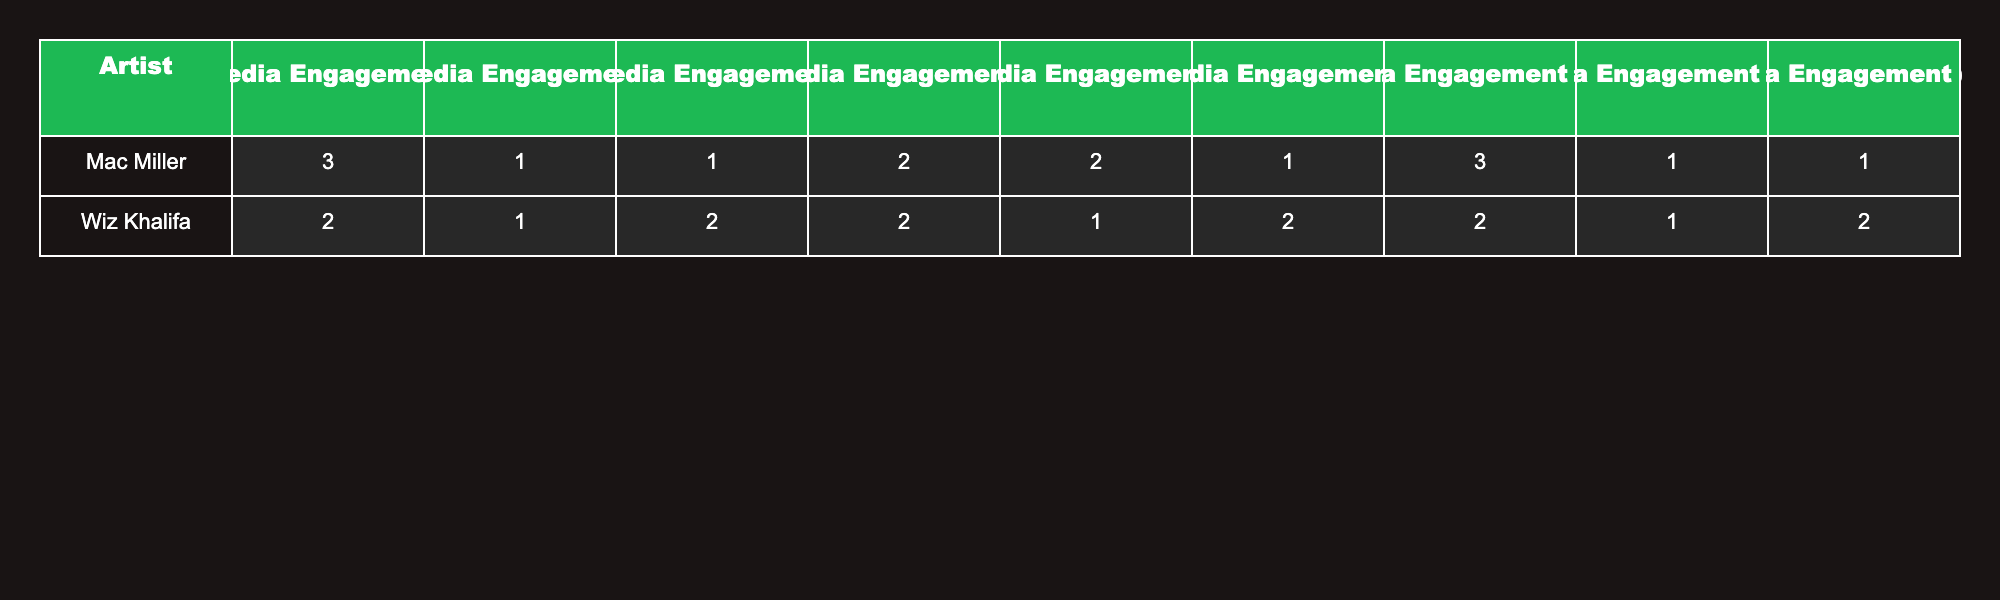What is the album with the highest likes? By examining the likes column in the table, I see that "Swimming" by Mac Miller has the highest value at 50000 likes.
Answer: Swimming Which artist has the most comments across their albums? Looking through the comments data for each artist, Mac Miller's albums have a total of 7000 comments (1500 + 2000 + 1200 + 4000), whereas Wiz Khalifa has a total of 3500 comments (800 + 1000 + 950 + 700). Therefore, Mac Miller has the most comments.
Answer: Mac Miller Is there an album by Wiz Khalifa that has more shares than "Kicking Clouds"? "Kicking Clouds" has 3500 shares. Comparing with Wiz Khalifa's albums, none exceed that: "The Saga Continues" has 2500, "The Last Dance" has 2000, "The Plan" has 2800, and "The Creator" has 2200. Therefore, there is no album that has more shares.
Answer: No What is the average number of likes for Mac Miller's albums? Mac Miller has four albums: "Good News," "Circles," "Kicking Clouds," and "Swimming." Their likes are 25000, 32000, 20000, and 50000, respectively. Sum equals 127000, and averaging over 4 albums gives 127000 / 4 = 31750.
Answer: 31750 Does "The Last Dance" have more likes than "The Saga Continues"? "The Last Dance" has 15000 likes while "The Saga Continues" has 18000 likes. Since 15000 is less than 18000, "The Last Dance" does not have more likes.
Answer: No Which album has the least shares? By comparing the shares among all albums, "The Last Dance" by Wiz Khalifa has the least shares at 2000.
Answer: The Last Dance What is the difference in total likes between the highest and lowest album by Wiz Khalifa? Wiz Khalifa's highest likes are 24000 from "Khalifa" and the lowest is 15000 from "The Last Dance." Calculating the difference gives us 24000 - 15000 = 9000.
Answer: 9000 What is the total social media engagement (likes, shares, comments) for the album "Circles"? For "Circles," likes are 32000, shares are 4000, and comments are 2000. Adding these gives 32000 + 4000 + 2000 = 38000.
Answer: 38000 